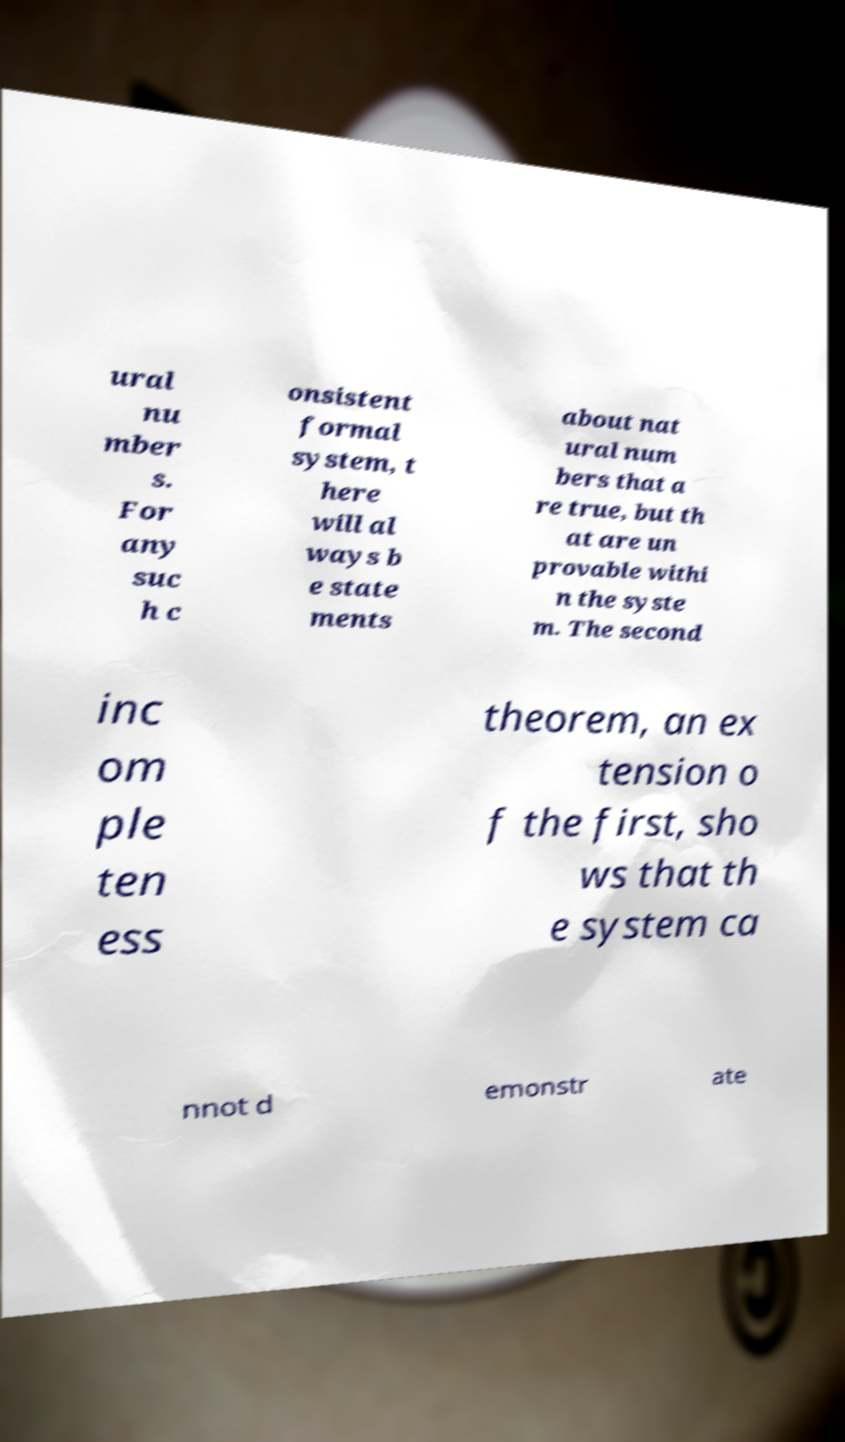Please identify and transcribe the text found in this image. ural nu mber s. For any suc h c onsistent formal system, t here will al ways b e state ments about nat ural num bers that a re true, but th at are un provable withi n the syste m. The second inc om ple ten ess theorem, an ex tension o f the first, sho ws that th e system ca nnot d emonstr ate 